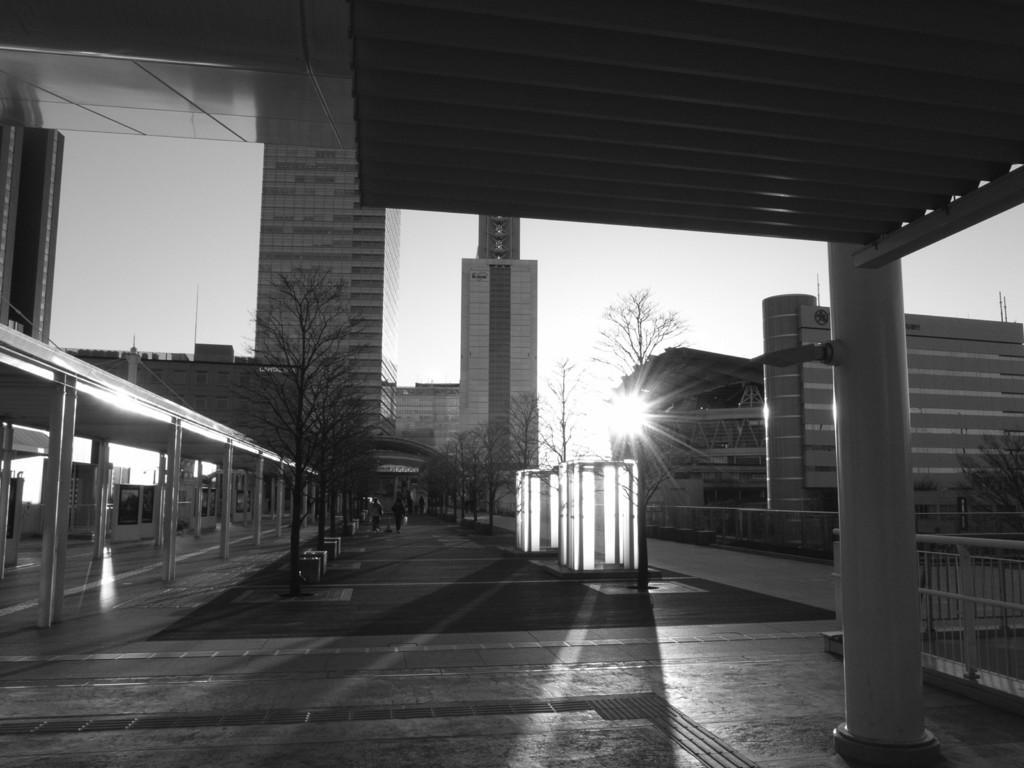Describe this image in one or two sentences. This is a black and white image. At the top it is a building. In the center of the picture there are trees and pavement. In the background there are buildings. On the right there are trees and railing. On the left there are buildings. It is sunny. 